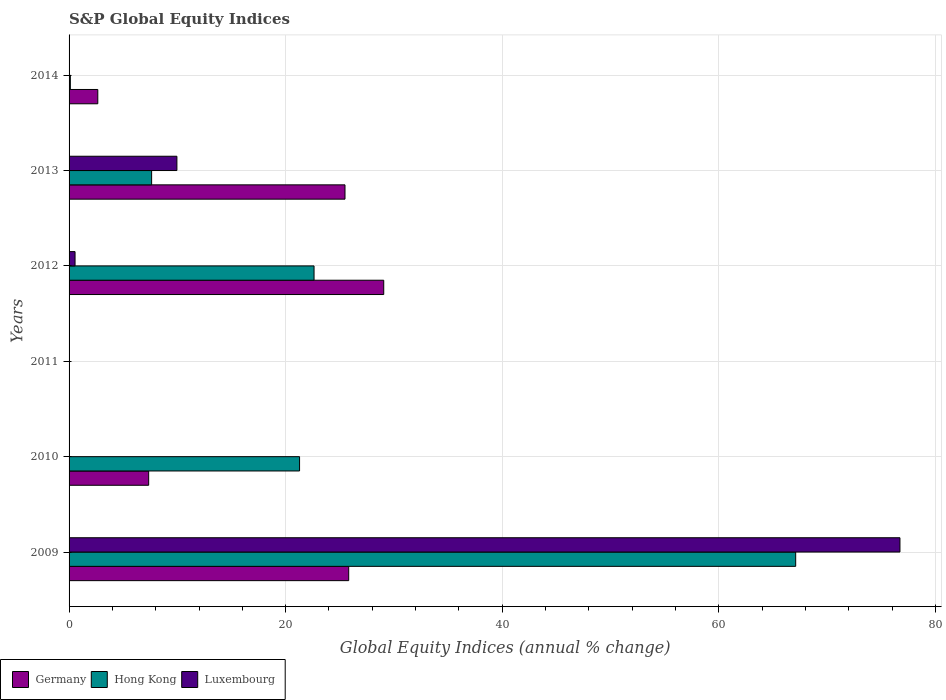How many different coloured bars are there?
Offer a very short reply. 3. What is the global equity indices in Germany in 2011?
Your answer should be compact. 0. Across all years, what is the maximum global equity indices in Luxembourg?
Provide a succinct answer. 76.73. What is the total global equity indices in Germany in the graph?
Your answer should be compact. 90.37. What is the difference between the global equity indices in Hong Kong in 2010 and that in 2014?
Your answer should be very brief. 21.17. What is the difference between the global equity indices in Luxembourg in 2011 and the global equity indices in Germany in 2014?
Offer a very short reply. -2.65. What is the average global equity indices in Germany per year?
Make the answer very short. 15.06. In the year 2009, what is the difference between the global equity indices in Hong Kong and global equity indices in Luxembourg?
Make the answer very short. -9.63. In how many years, is the global equity indices in Germany greater than 4 %?
Offer a terse response. 4. What is the ratio of the global equity indices in Germany in 2010 to that in 2013?
Offer a terse response. 0.29. Is the global equity indices in Germany in 2009 less than that in 2012?
Keep it short and to the point. Yes. Is the difference between the global equity indices in Hong Kong in 2009 and 2013 greater than the difference between the global equity indices in Luxembourg in 2009 and 2013?
Give a very brief answer. No. What is the difference between the highest and the second highest global equity indices in Luxembourg?
Offer a terse response. 66.77. What is the difference between the highest and the lowest global equity indices in Hong Kong?
Give a very brief answer. 67.1. Is the sum of the global equity indices in Hong Kong in 2012 and 2013 greater than the maximum global equity indices in Germany across all years?
Offer a very short reply. Yes. Is it the case that in every year, the sum of the global equity indices in Germany and global equity indices in Luxembourg is greater than the global equity indices in Hong Kong?
Your response must be concise. No. How many bars are there?
Your answer should be very brief. 13. Are all the bars in the graph horizontal?
Your answer should be very brief. Yes. How many years are there in the graph?
Offer a very short reply. 6. Are the values on the major ticks of X-axis written in scientific E-notation?
Your response must be concise. No. Does the graph contain grids?
Provide a short and direct response. Yes. Where does the legend appear in the graph?
Make the answer very short. Bottom left. How are the legend labels stacked?
Keep it short and to the point. Horizontal. What is the title of the graph?
Ensure brevity in your answer.  S&P Global Equity Indices. What is the label or title of the X-axis?
Offer a very short reply. Global Equity Indices (annual % change). What is the label or title of the Y-axis?
Provide a succinct answer. Years. What is the Global Equity Indices (annual % change) of Germany in 2009?
Provide a short and direct response. 25.82. What is the Global Equity Indices (annual % change) of Hong Kong in 2009?
Your answer should be very brief. 67.1. What is the Global Equity Indices (annual % change) of Luxembourg in 2009?
Ensure brevity in your answer.  76.73. What is the Global Equity Indices (annual % change) of Germany in 2010?
Offer a very short reply. 7.35. What is the Global Equity Indices (annual % change) in Hong Kong in 2010?
Provide a succinct answer. 21.29. What is the Global Equity Indices (annual % change) of Germany in 2012?
Your answer should be very brief. 29.06. What is the Global Equity Indices (annual % change) in Hong Kong in 2012?
Your answer should be very brief. 22.62. What is the Global Equity Indices (annual % change) of Luxembourg in 2012?
Offer a terse response. 0.55. What is the Global Equity Indices (annual % change) of Germany in 2013?
Ensure brevity in your answer.  25.48. What is the Global Equity Indices (annual % change) in Hong Kong in 2013?
Make the answer very short. 7.62. What is the Global Equity Indices (annual % change) in Luxembourg in 2013?
Offer a terse response. 9.96. What is the Global Equity Indices (annual % change) of Germany in 2014?
Ensure brevity in your answer.  2.65. What is the Global Equity Indices (annual % change) of Hong Kong in 2014?
Ensure brevity in your answer.  0.12. What is the Global Equity Indices (annual % change) of Luxembourg in 2014?
Your response must be concise. 0. Across all years, what is the maximum Global Equity Indices (annual % change) in Germany?
Give a very brief answer. 29.06. Across all years, what is the maximum Global Equity Indices (annual % change) of Hong Kong?
Your answer should be very brief. 67.1. Across all years, what is the maximum Global Equity Indices (annual % change) of Luxembourg?
Offer a terse response. 76.73. Across all years, what is the minimum Global Equity Indices (annual % change) in Hong Kong?
Ensure brevity in your answer.  0. Across all years, what is the minimum Global Equity Indices (annual % change) of Luxembourg?
Provide a short and direct response. 0. What is the total Global Equity Indices (annual % change) in Germany in the graph?
Provide a short and direct response. 90.37. What is the total Global Equity Indices (annual % change) of Hong Kong in the graph?
Make the answer very short. 118.76. What is the total Global Equity Indices (annual % change) of Luxembourg in the graph?
Your answer should be very brief. 87.24. What is the difference between the Global Equity Indices (annual % change) of Germany in 2009 and that in 2010?
Provide a short and direct response. 18.47. What is the difference between the Global Equity Indices (annual % change) in Hong Kong in 2009 and that in 2010?
Provide a succinct answer. 45.82. What is the difference between the Global Equity Indices (annual % change) of Germany in 2009 and that in 2012?
Provide a short and direct response. -3.24. What is the difference between the Global Equity Indices (annual % change) in Hong Kong in 2009 and that in 2012?
Offer a terse response. 44.48. What is the difference between the Global Equity Indices (annual % change) of Luxembourg in 2009 and that in 2012?
Provide a short and direct response. 76.18. What is the difference between the Global Equity Indices (annual % change) in Germany in 2009 and that in 2013?
Your response must be concise. 0.34. What is the difference between the Global Equity Indices (annual % change) of Hong Kong in 2009 and that in 2013?
Provide a short and direct response. 59.48. What is the difference between the Global Equity Indices (annual % change) of Luxembourg in 2009 and that in 2013?
Keep it short and to the point. 66.77. What is the difference between the Global Equity Indices (annual % change) in Germany in 2009 and that in 2014?
Ensure brevity in your answer.  23.17. What is the difference between the Global Equity Indices (annual % change) of Hong Kong in 2009 and that in 2014?
Your answer should be very brief. 66.99. What is the difference between the Global Equity Indices (annual % change) of Germany in 2010 and that in 2012?
Give a very brief answer. -21.71. What is the difference between the Global Equity Indices (annual % change) of Hong Kong in 2010 and that in 2012?
Provide a succinct answer. -1.34. What is the difference between the Global Equity Indices (annual % change) of Germany in 2010 and that in 2013?
Your answer should be compact. -18.13. What is the difference between the Global Equity Indices (annual % change) of Hong Kong in 2010 and that in 2013?
Offer a very short reply. 13.66. What is the difference between the Global Equity Indices (annual % change) in Germany in 2010 and that in 2014?
Provide a succinct answer. 4.7. What is the difference between the Global Equity Indices (annual % change) in Hong Kong in 2010 and that in 2014?
Keep it short and to the point. 21.17. What is the difference between the Global Equity Indices (annual % change) in Germany in 2012 and that in 2013?
Offer a very short reply. 3.58. What is the difference between the Global Equity Indices (annual % change) of Hong Kong in 2012 and that in 2013?
Ensure brevity in your answer.  15. What is the difference between the Global Equity Indices (annual % change) in Luxembourg in 2012 and that in 2013?
Your response must be concise. -9.41. What is the difference between the Global Equity Indices (annual % change) in Germany in 2012 and that in 2014?
Give a very brief answer. 26.41. What is the difference between the Global Equity Indices (annual % change) in Hong Kong in 2012 and that in 2014?
Offer a very short reply. 22.51. What is the difference between the Global Equity Indices (annual % change) in Germany in 2013 and that in 2014?
Your answer should be compact. 22.83. What is the difference between the Global Equity Indices (annual % change) of Hong Kong in 2013 and that in 2014?
Your answer should be compact. 7.51. What is the difference between the Global Equity Indices (annual % change) in Germany in 2009 and the Global Equity Indices (annual % change) in Hong Kong in 2010?
Offer a terse response. 4.54. What is the difference between the Global Equity Indices (annual % change) in Germany in 2009 and the Global Equity Indices (annual % change) in Hong Kong in 2012?
Offer a terse response. 3.2. What is the difference between the Global Equity Indices (annual % change) of Germany in 2009 and the Global Equity Indices (annual % change) of Luxembourg in 2012?
Provide a succinct answer. 25.27. What is the difference between the Global Equity Indices (annual % change) in Hong Kong in 2009 and the Global Equity Indices (annual % change) in Luxembourg in 2012?
Your response must be concise. 66.55. What is the difference between the Global Equity Indices (annual % change) in Germany in 2009 and the Global Equity Indices (annual % change) in Hong Kong in 2013?
Keep it short and to the point. 18.2. What is the difference between the Global Equity Indices (annual % change) of Germany in 2009 and the Global Equity Indices (annual % change) of Luxembourg in 2013?
Keep it short and to the point. 15.87. What is the difference between the Global Equity Indices (annual % change) in Hong Kong in 2009 and the Global Equity Indices (annual % change) in Luxembourg in 2013?
Give a very brief answer. 57.14. What is the difference between the Global Equity Indices (annual % change) in Germany in 2009 and the Global Equity Indices (annual % change) in Hong Kong in 2014?
Your answer should be very brief. 25.71. What is the difference between the Global Equity Indices (annual % change) in Germany in 2010 and the Global Equity Indices (annual % change) in Hong Kong in 2012?
Your response must be concise. -15.27. What is the difference between the Global Equity Indices (annual % change) of Germany in 2010 and the Global Equity Indices (annual % change) of Luxembourg in 2012?
Make the answer very short. 6.8. What is the difference between the Global Equity Indices (annual % change) in Hong Kong in 2010 and the Global Equity Indices (annual % change) in Luxembourg in 2012?
Offer a terse response. 20.73. What is the difference between the Global Equity Indices (annual % change) of Germany in 2010 and the Global Equity Indices (annual % change) of Hong Kong in 2013?
Your response must be concise. -0.27. What is the difference between the Global Equity Indices (annual % change) of Germany in 2010 and the Global Equity Indices (annual % change) of Luxembourg in 2013?
Offer a very short reply. -2.61. What is the difference between the Global Equity Indices (annual % change) of Hong Kong in 2010 and the Global Equity Indices (annual % change) of Luxembourg in 2013?
Keep it short and to the point. 11.33. What is the difference between the Global Equity Indices (annual % change) of Germany in 2010 and the Global Equity Indices (annual % change) of Hong Kong in 2014?
Keep it short and to the point. 7.23. What is the difference between the Global Equity Indices (annual % change) of Germany in 2012 and the Global Equity Indices (annual % change) of Hong Kong in 2013?
Your answer should be compact. 21.44. What is the difference between the Global Equity Indices (annual % change) in Germany in 2012 and the Global Equity Indices (annual % change) in Luxembourg in 2013?
Ensure brevity in your answer.  19.1. What is the difference between the Global Equity Indices (annual % change) in Hong Kong in 2012 and the Global Equity Indices (annual % change) in Luxembourg in 2013?
Your answer should be compact. 12.67. What is the difference between the Global Equity Indices (annual % change) in Germany in 2012 and the Global Equity Indices (annual % change) in Hong Kong in 2014?
Ensure brevity in your answer.  28.94. What is the difference between the Global Equity Indices (annual % change) in Germany in 2013 and the Global Equity Indices (annual % change) in Hong Kong in 2014?
Offer a terse response. 25.36. What is the average Global Equity Indices (annual % change) in Germany per year?
Your answer should be compact. 15.06. What is the average Global Equity Indices (annual % change) in Hong Kong per year?
Give a very brief answer. 19.79. What is the average Global Equity Indices (annual % change) in Luxembourg per year?
Your response must be concise. 14.54. In the year 2009, what is the difference between the Global Equity Indices (annual % change) in Germany and Global Equity Indices (annual % change) in Hong Kong?
Your response must be concise. -41.28. In the year 2009, what is the difference between the Global Equity Indices (annual % change) of Germany and Global Equity Indices (annual % change) of Luxembourg?
Make the answer very short. -50.91. In the year 2009, what is the difference between the Global Equity Indices (annual % change) in Hong Kong and Global Equity Indices (annual % change) in Luxembourg?
Give a very brief answer. -9.63. In the year 2010, what is the difference between the Global Equity Indices (annual % change) of Germany and Global Equity Indices (annual % change) of Hong Kong?
Ensure brevity in your answer.  -13.94. In the year 2012, what is the difference between the Global Equity Indices (annual % change) in Germany and Global Equity Indices (annual % change) in Hong Kong?
Provide a short and direct response. 6.44. In the year 2012, what is the difference between the Global Equity Indices (annual % change) of Germany and Global Equity Indices (annual % change) of Luxembourg?
Make the answer very short. 28.51. In the year 2012, what is the difference between the Global Equity Indices (annual % change) of Hong Kong and Global Equity Indices (annual % change) of Luxembourg?
Provide a succinct answer. 22.07. In the year 2013, what is the difference between the Global Equity Indices (annual % change) of Germany and Global Equity Indices (annual % change) of Hong Kong?
Ensure brevity in your answer.  17.86. In the year 2013, what is the difference between the Global Equity Indices (annual % change) in Germany and Global Equity Indices (annual % change) in Luxembourg?
Keep it short and to the point. 15.52. In the year 2013, what is the difference between the Global Equity Indices (annual % change) of Hong Kong and Global Equity Indices (annual % change) of Luxembourg?
Make the answer very short. -2.33. In the year 2014, what is the difference between the Global Equity Indices (annual % change) in Germany and Global Equity Indices (annual % change) in Hong Kong?
Offer a terse response. 2.54. What is the ratio of the Global Equity Indices (annual % change) in Germany in 2009 to that in 2010?
Ensure brevity in your answer.  3.51. What is the ratio of the Global Equity Indices (annual % change) in Hong Kong in 2009 to that in 2010?
Your response must be concise. 3.15. What is the ratio of the Global Equity Indices (annual % change) in Germany in 2009 to that in 2012?
Offer a terse response. 0.89. What is the ratio of the Global Equity Indices (annual % change) of Hong Kong in 2009 to that in 2012?
Offer a very short reply. 2.97. What is the ratio of the Global Equity Indices (annual % change) of Luxembourg in 2009 to that in 2012?
Provide a succinct answer. 138.88. What is the ratio of the Global Equity Indices (annual % change) of Germany in 2009 to that in 2013?
Make the answer very short. 1.01. What is the ratio of the Global Equity Indices (annual % change) of Hong Kong in 2009 to that in 2013?
Make the answer very short. 8.8. What is the ratio of the Global Equity Indices (annual % change) of Luxembourg in 2009 to that in 2013?
Provide a succinct answer. 7.71. What is the ratio of the Global Equity Indices (annual % change) in Germany in 2009 to that in 2014?
Provide a succinct answer. 9.74. What is the ratio of the Global Equity Indices (annual % change) in Hong Kong in 2009 to that in 2014?
Make the answer very short. 571.85. What is the ratio of the Global Equity Indices (annual % change) in Germany in 2010 to that in 2012?
Your response must be concise. 0.25. What is the ratio of the Global Equity Indices (annual % change) of Hong Kong in 2010 to that in 2012?
Provide a succinct answer. 0.94. What is the ratio of the Global Equity Indices (annual % change) of Germany in 2010 to that in 2013?
Your response must be concise. 0.29. What is the ratio of the Global Equity Indices (annual % change) in Hong Kong in 2010 to that in 2013?
Make the answer very short. 2.79. What is the ratio of the Global Equity Indices (annual % change) of Germany in 2010 to that in 2014?
Your response must be concise. 2.77. What is the ratio of the Global Equity Indices (annual % change) in Hong Kong in 2010 to that in 2014?
Ensure brevity in your answer.  181.4. What is the ratio of the Global Equity Indices (annual % change) of Germany in 2012 to that in 2013?
Offer a very short reply. 1.14. What is the ratio of the Global Equity Indices (annual % change) of Hong Kong in 2012 to that in 2013?
Offer a very short reply. 2.97. What is the ratio of the Global Equity Indices (annual % change) of Luxembourg in 2012 to that in 2013?
Offer a terse response. 0.06. What is the ratio of the Global Equity Indices (annual % change) of Germany in 2012 to that in 2014?
Make the answer very short. 10.95. What is the ratio of the Global Equity Indices (annual % change) of Hong Kong in 2012 to that in 2014?
Offer a very short reply. 192.8. What is the ratio of the Global Equity Indices (annual % change) of Germany in 2013 to that in 2014?
Offer a very short reply. 9.61. What is the ratio of the Global Equity Indices (annual % change) of Hong Kong in 2013 to that in 2014?
Offer a very short reply. 64.98. What is the difference between the highest and the second highest Global Equity Indices (annual % change) of Germany?
Your answer should be compact. 3.24. What is the difference between the highest and the second highest Global Equity Indices (annual % change) in Hong Kong?
Make the answer very short. 44.48. What is the difference between the highest and the second highest Global Equity Indices (annual % change) of Luxembourg?
Provide a short and direct response. 66.77. What is the difference between the highest and the lowest Global Equity Indices (annual % change) in Germany?
Make the answer very short. 29.06. What is the difference between the highest and the lowest Global Equity Indices (annual % change) in Hong Kong?
Your response must be concise. 67.1. What is the difference between the highest and the lowest Global Equity Indices (annual % change) of Luxembourg?
Provide a succinct answer. 76.73. 